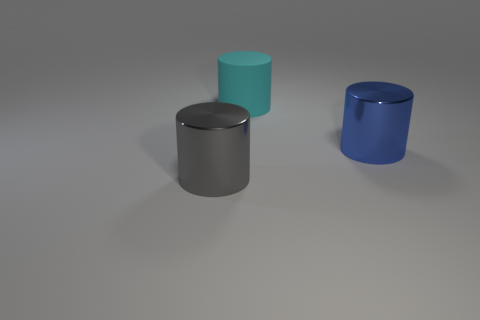The large rubber thing is what color?
Your response must be concise. Cyan. Do the large metal thing to the right of the big cyan cylinder and the gray metallic thing have the same shape?
Your answer should be very brief. Yes. There is a large object that is on the right side of the big thing behind the large metallic cylinder that is right of the gray thing; what shape is it?
Keep it short and to the point. Cylinder. There is a large object that is behind the large blue thing; what material is it?
Provide a short and direct response. Rubber. There is another matte object that is the same size as the blue object; what is its color?
Offer a terse response. Cyan. What number of other things are there of the same shape as the big cyan object?
Keep it short and to the point. 2. Do the matte cylinder and the gray cylinder have the same size?
Provide a succinct answer. Yes. Are there more big cylinders right of the rubber object than cyan matte objects that are on the right side of the blue metal cylinder?
Offer a terse response. Yes. How many other things are there of the same size as the cyan cylinder?
Your answer should be very brief. 2. Are there more large blue metallic cylinders that are in front of the big cyan matte cylinder than green balls?
Keep it short and to the point. Yes. 